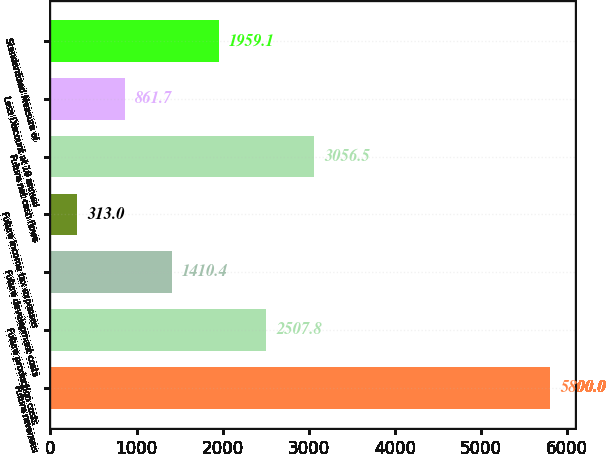Convert chart to OTSL. <chart><loc_0><loc_0><loc_500><loc_500><bar_chart><fcel>Future revenues<fcel>Future production costs<fcel>Future development costs<fcel>Future income tax expenses<fcel>Future net cash flows<fcel>Less Discount at 10 annual<fcel>Standardized Measure of<nl><fcel>5800<fcel>2507.8<fcel>1410.4<fcel>313<fcel>3056.5<fcel>861.7<fcel>1959.1<nl></chart> 